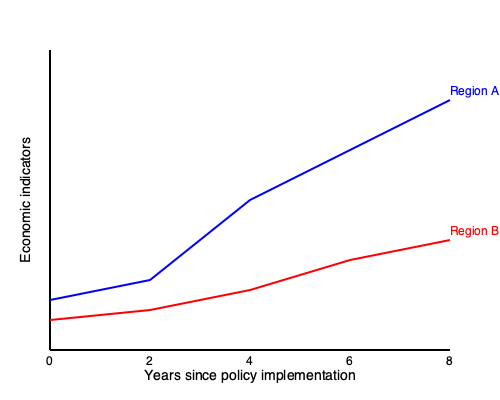The graph shows economic indicators for two regions (A and B) over 8 years following the implementation of strict immigration policies. What can be inferred about the difference in economic impact between the two regions, and how might this relate to their respective approaches to immigration? To analyze the graph and draw conclusions:

1. Observe the trends:
   - Region A (blue line): Shows a steep upward trend, indicating significant economic growth.
   - Region B (red line): Shows a slight downward trend, suggesting economic decline or stagnation.

2. Compare the slopes:
   - Region A's slope is much steeper, implying faster economic growth.
   - Region B's slope is slightly negative, indicating a gradual decline.

3. Consider the starting points:
   - Both regions start at different levels, with Region A lower than Region B.
   - By year 8, Region A has surpassed Region B economically.

4. Interpret the data in context:
   - The diverging trends suggest different approaches to immigration policies.
   - Region A's growth might indicate a more flexible or integrated approach to immigration.
   - Region B's decline could suggest stricter policies leading to labor shortages or reduced economic dynamism.

5. Consider potential factors:
   - Region A may have attracted skilled immigrants or benefited from diverse workforce.
   - Region B might be experiencing brain drain or lack of workforce in key sectors.

6. Relate to vulnerable populations:
   - The economic decline in Region B could disproportionately affect vulnerable groups.
   - Region A's growth might provide more opportunities for both natives and immigrants.

Conclusion: The graph suggests that Region A's approach to immigration has led to stronger economic growth, while Region B's stricter policies may have hindered economic progress, potentially impacting vulnerable populations more severely.
Answer: Region A's flexible immigration approach likely led to economic growth, while Region B's stricter policies may have caused economic decline, potentially harming vulnerable populations. 